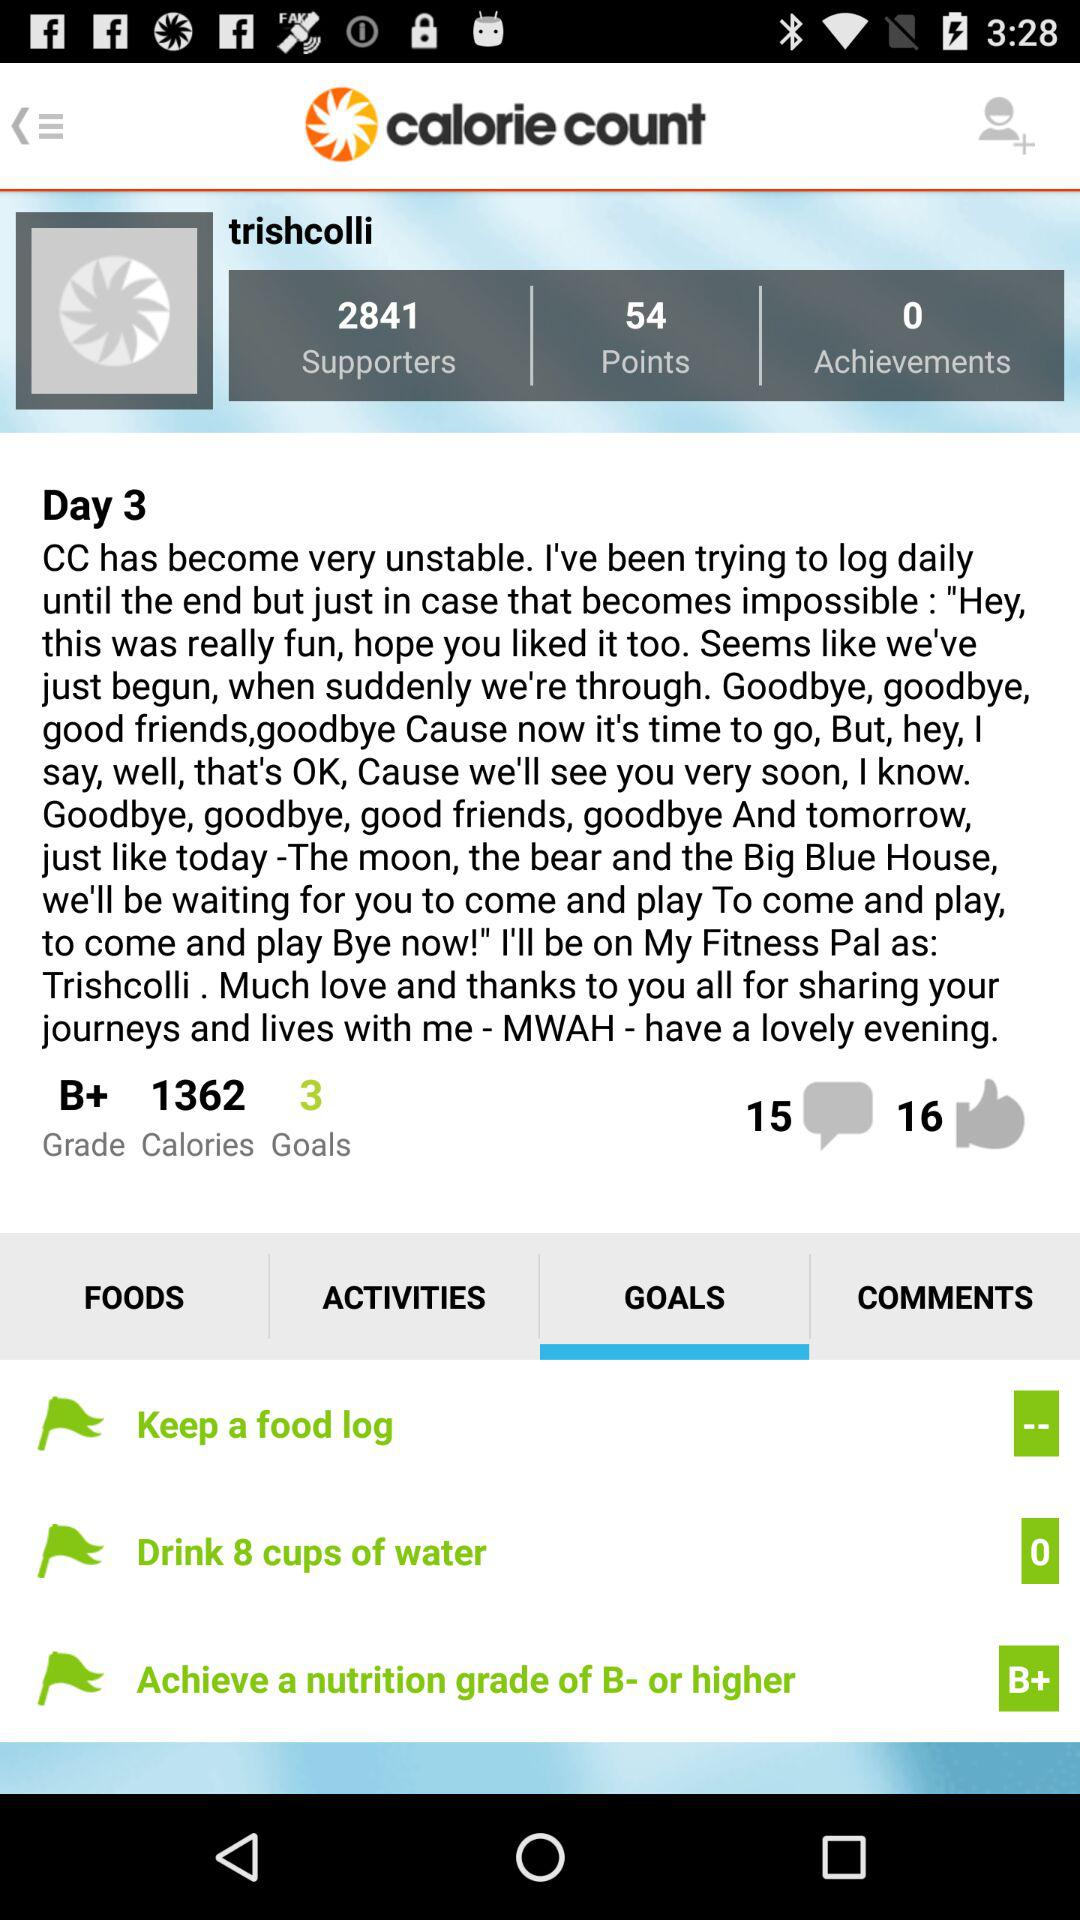How many days has the user been logging food for?
Answer the question using a single word or phrase. 3 